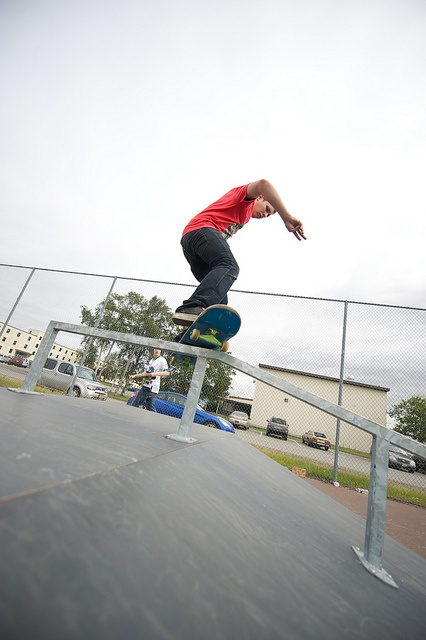Describe the objects in this image and their specific colors. I can see people in darkgray, black, gray, salmon, and brown tones, skateboard in darkgray, darkblue, black, gray, and blue tones, car in darkgray, gray, and lightgray tones, car in darkgray, gray, blue, and navy tones, and people in darkgray, lightgray, gray, and black tones in this image. 